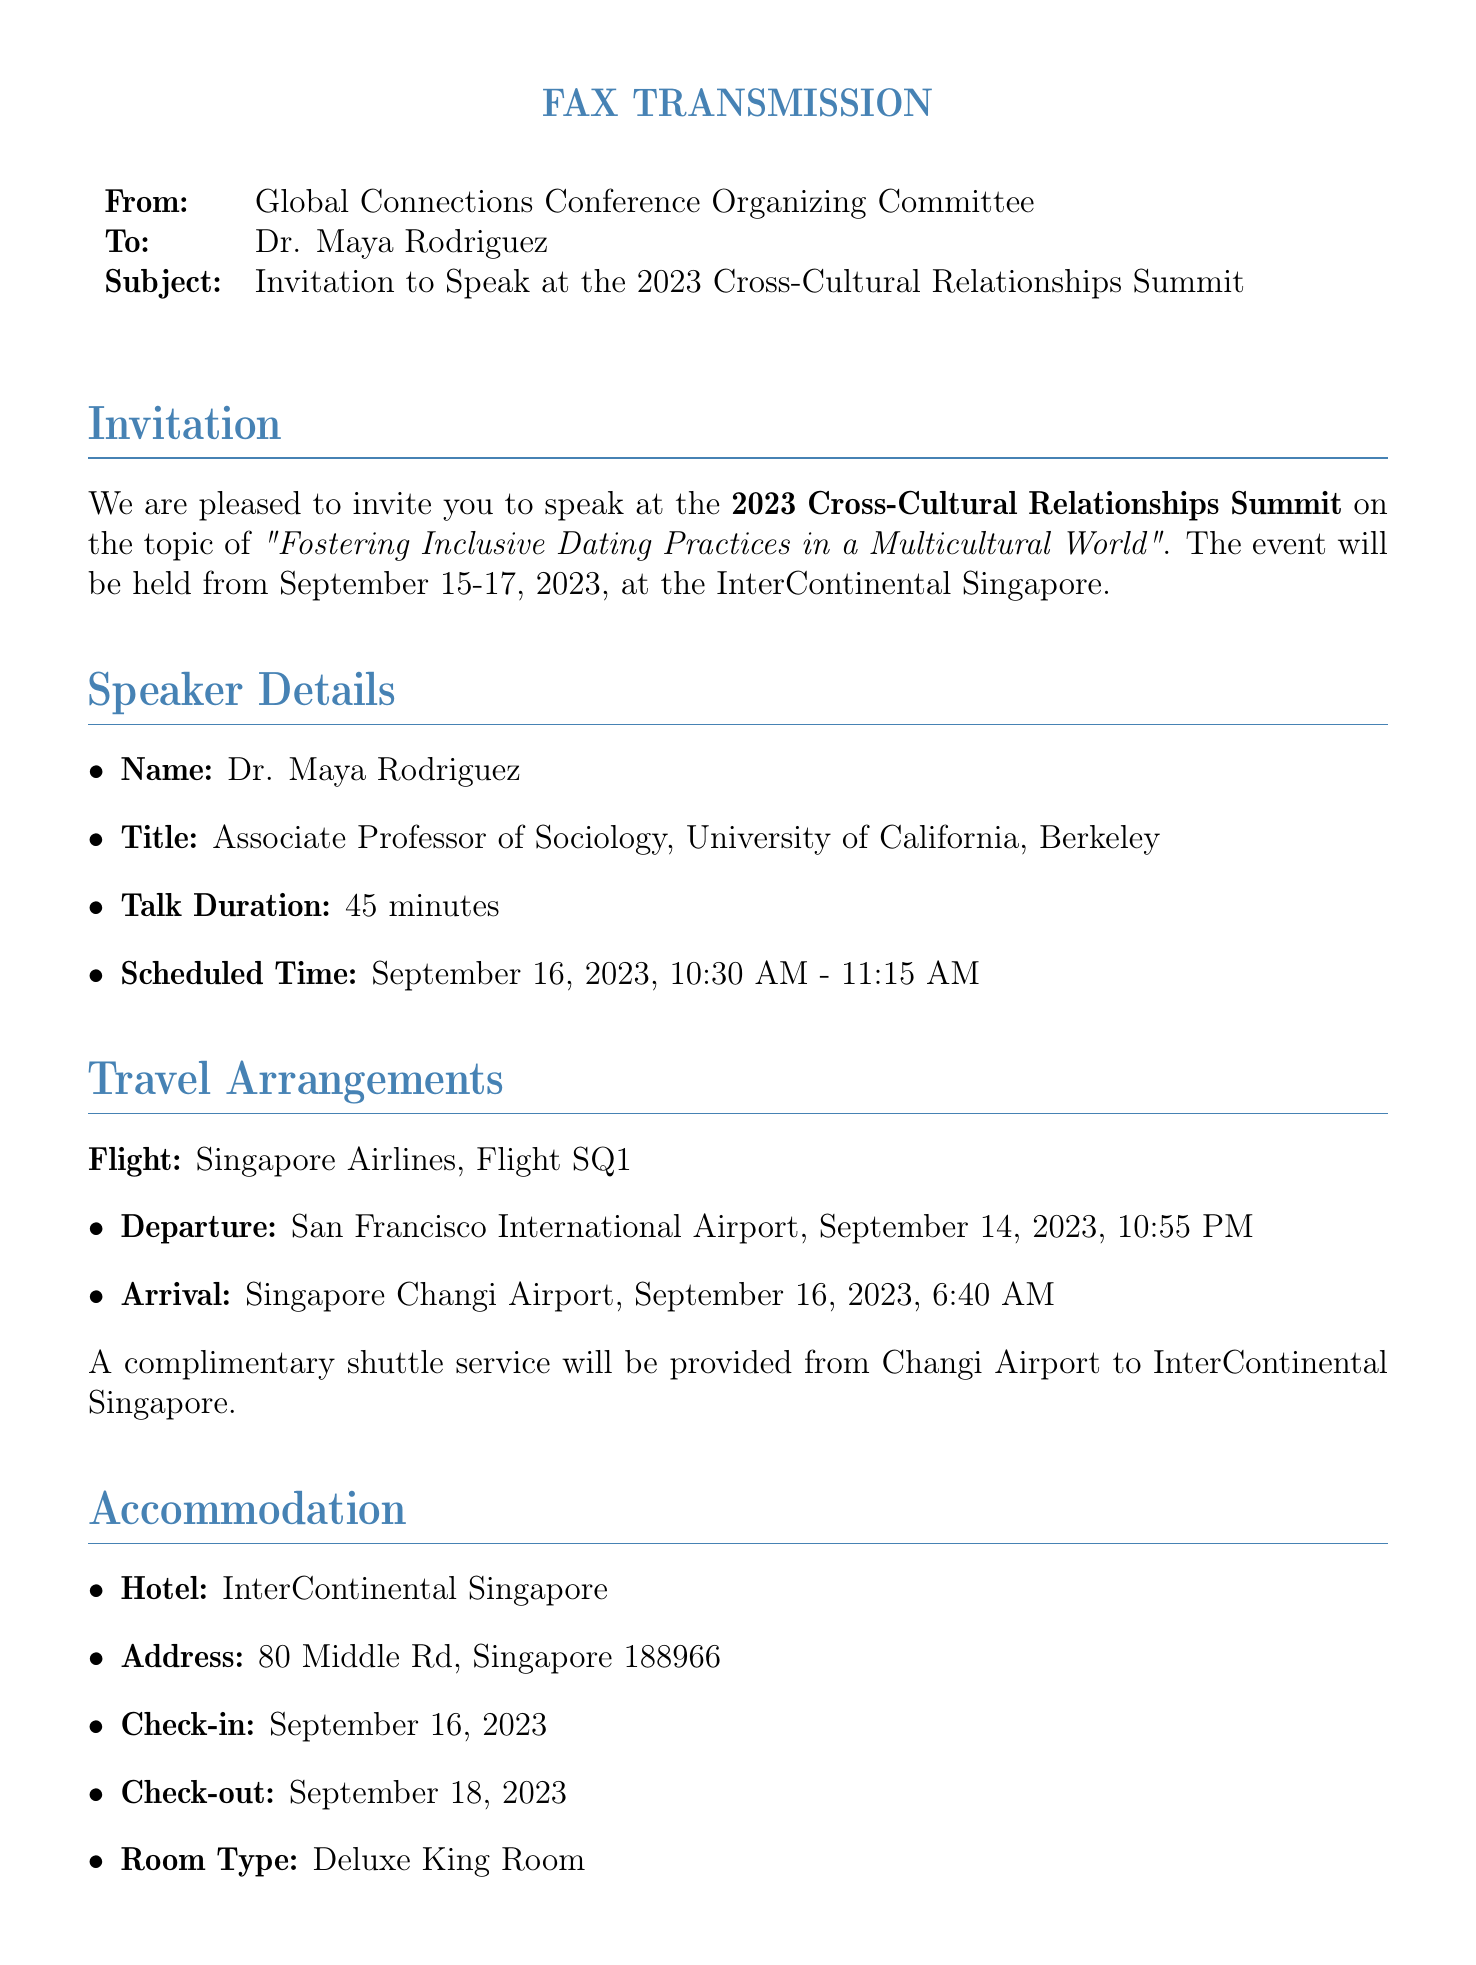What is the title of Dr. Maya Rodriguez's talk? The title is stated in the invitation section of the document as "Fostering Inclusive Dating Practices in a Multicultural World".
Answer: Fostering Inclusive Dating Practices in a Multicultural World When is the conference scheduled to take place? The date is specified in the invitation section: the conference will occur from September 15-17, 2023.
Answer: September 15-17, 2023 What airline is Dr. Maya Rodriguez flying with? The flight details mention that she will be traveling with Singapore Airlines.
Answer: Singapore Airlines What is the check-in date for the hotel? The check-in date is provided in the accommodation section, listed as September 16, 2023.
Answer: September 16, 2023 Who is the conference coordinator? The contact information lists Ms. Aisha Tan as the conference coordinator.
Answer: Aisha Tan What is the expected number of attendees? The document mentions that there will be 500+ relationship experts, sociologists, and advocates.
Answer: 500+ What is the dress code for the conference? The document specifies the dress code as smart casual in the additional information section.
Answer: Smart casual What is the address of the InterContinental Singapore? The address is stated in the accommodation section as 80 Middle Rd, Singapore 188966.
Answer: 80 Middle Rd, Singapore 188966 At what time is Dr. Maya Rodriguez's talk scheduled? The scheduled time for her talk is mentioned in the speaker details as 10:30 AM - 11:15 AM on September 16, 2023.
Answer: 10:30 AM - 11:15 AM 